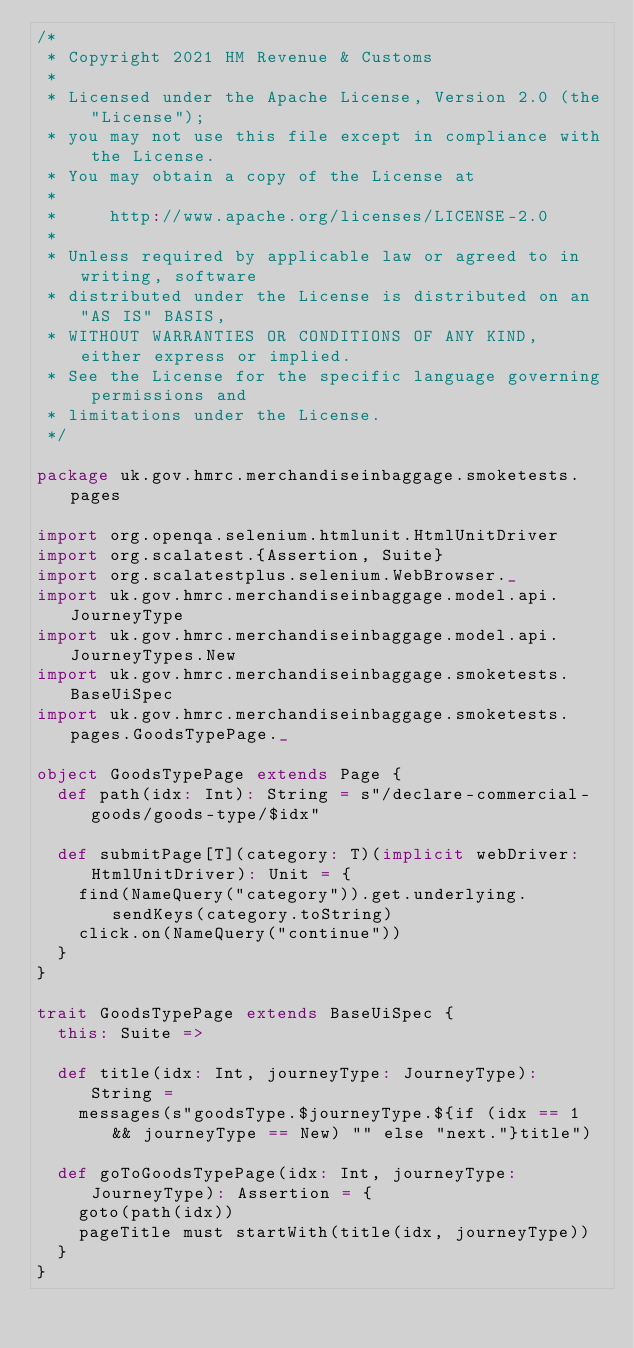Convert code to text. <code><loc_0><loc_0><loc_500><loc_500><_Scala_>/*
 * Copyright 2021 HM Revenue & Customs
 *
 * Licensed under the Apache License, Version 2.0 (the "License");
 * you may not use this file except in compliance with the License.
 * You may obtain a copy of the License at
 *
 *     http://www.apache.org/licenses/LICENSE-2.0
 *
 * Unless required by applicable law or agreed to in writing, software
 * distributed under the License is distributed on an "AS IS" BASIS,
 * WITHOUT WARRANTIES OR CONDITIONS OF ANY KIND, either express or implied.
 * See the License for the specific language governing permissions and
 * limitations under the License.
 */

package uk.gov.hmrc.merchandiseinbaggage.smoketests.pages

import org.openqa.selenium.htmlunit.HtmlUnitDriver
import org.scalatest.{Assertion, Suite}
import org.scalatestplus.selenium.WebBrowser._
import uk.gov.hmrc.merchandiseinbaggage.model.api.JourneyType
import uk.gov.hmrc.merchandiseinbaggage.model.api.JourneyTypes.New
import uk.gov.hmrc.merchandiseinbaggage.smoketests.BaseUiSpec
import uk.gov.hmrc.merchandiseinbaggage.smoketests.pages.GoodsTypePage._

object GoodsTypePage extends Page {
  def path(idx: Int): String = s"/declare-commercial-goods/goods-type/$idx"

  def submitPage[T](category: T)(implicit webDriver: HtmlUnitDriver): Unit = {
    find(NameQuery("category")).get.underlying.sendKeys(category.toString)
    click.on(NameQuery("continue"))
  }
}

trait GoodsTypePage extends BaseUiSpec {
  this: Suite =>

  def title(idx: Int, journeyType: JourneyType): String =
    messages(s"goodsType.$journeyType.${if (idx == 1 && journeyType == New) "" else "next."}title")

  def goToGoodsTypePage(idx: Int, journeyType: JourneyType): Assertion = {
    goto(path(idx))
    pageTitle must startWith(title(idx, journeyType))
  }
}
</code> 